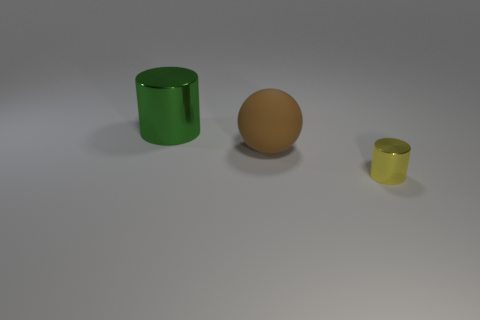Does the cylinder that is in front of the large green shiny cylinder have the same material as the big green object?
Your answer should be very brief. Yes. What is the shape of the shiny thing to the left of the tiny thing?
Provide a succinct answer. Cylinder. What number of metallic things have the same size as the yellow metallic cylinder?
Offer a very short reply. 0. What size is the green metallic thing?
Your answer should be compact. Large. There is a green shiny cylinder; what number of things are behind it?
Provide a succinct answer. 0. There is another thing that is made of the same material as the big green object; what is its shape?
Make the answer very short. Cylinder. Are there fewer green metallic things that are behind the yellow metallic cylinder than green metallic things that are left of the large shiny cylinder?
Your answer should be compact. No. Are there more small yellow cylinders than large green metal cubes?
Make the answer very short. Yes. What material is the yellow cylinder?
Offer a terse response. Metal. What color is the shiny object in front of the big green thing?
Your answer should be very brief. Yellow. 